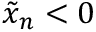Convert formula to latex. <formula><loc_0><loc_0><loc_500><loc_500>\tilde { x } _ { n } < 0</formula> 